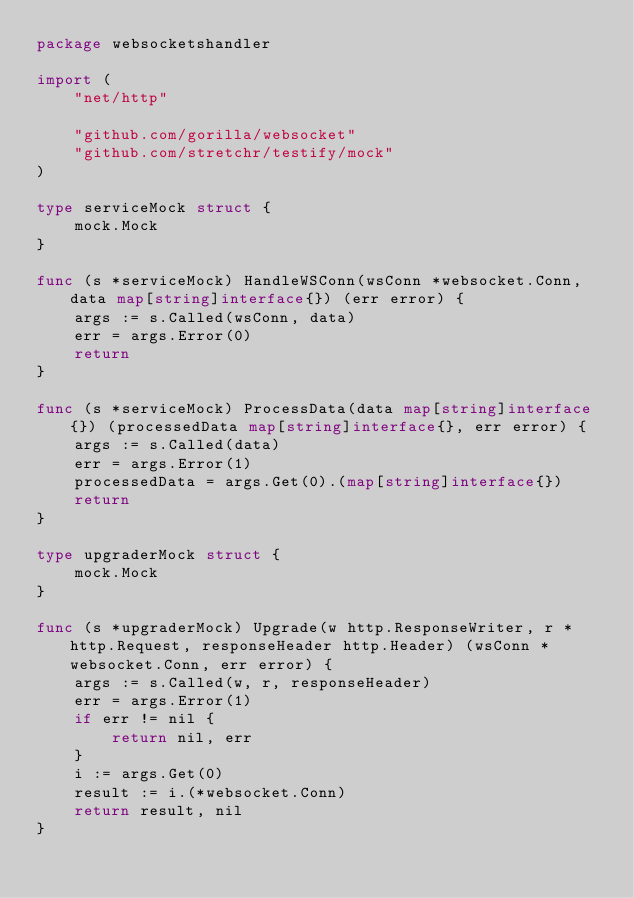Convert code to text. <code><loc_0><loc_0><loc_500><loc_500><_Go_>package websocketshandler

import (
	"net/http"

	"github.com/gorilla/websocket"
	"github.com/stretchr/testify/mock"
)

type serviceMock struct {
	mock.Mock
}

func (s *serviceMock) HandleWSConn(wsConn *websocket.Conn, data map[string]interface{}) (err error) {
	args := s.Called(wsConn, data)
	err = args.Error(0)
	return
}

func (s *serviceMock) ProcessData(data map[string]interface{}) (processedData map[string]interface{}, err error) {
	args := s.Called(data)
	err = args.Error(1)
	processedData = args.Get(0).(map[string]interface{})
	return
}

type upgraderMock struct {
	mock.Mock
}

func (s *upgraderMock) Upgrade(w http.ResponseWriter, r *http.Request, responseHeader http.Header) (wsConn *websocket.Conn, err error) {
	args := s.Called(w, r, responseHeader)
	err = args.Error(1)
	if err != nil {
		return nil, err
	}
	i := args.Get(0)
	result := i.(*websocket.Conn)
	return result, nil
}
</code> 